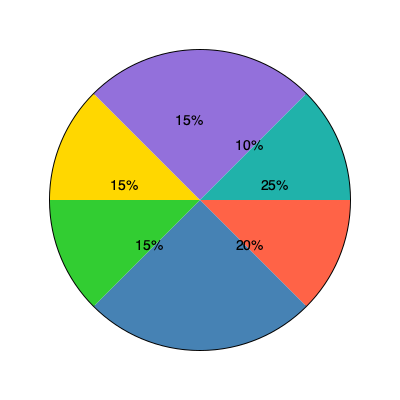In the pie chart depicting the allocation of public funds, what percentage of the budget is allocated to non-religious organizations if we assume that the two largest segments represent funding for religious institutions? To solve this problem, we need to follow these steps:

1. Identify the two largest segments in the pie chart:
   - The largest segment is 25% (red)
   - The second-largest segment is 20% (blue)

2. Assume these two segments represent funding for religious institutions:
   25% + 20% = 45% for religious organizations

3. Calculate the remaining percentage for non-religious organizations:
   100% - 45% = 55%

4. Verify by adding up the remaining segments:
   15% (green) + 15% (yellow) + 15% (purple) + 10% (teal) = 55%

Therefore, if we assume that the two largest segments represent funding for religious institutions, 55% of the budget is allocated to non-religious organizations.
Answer: 55% 